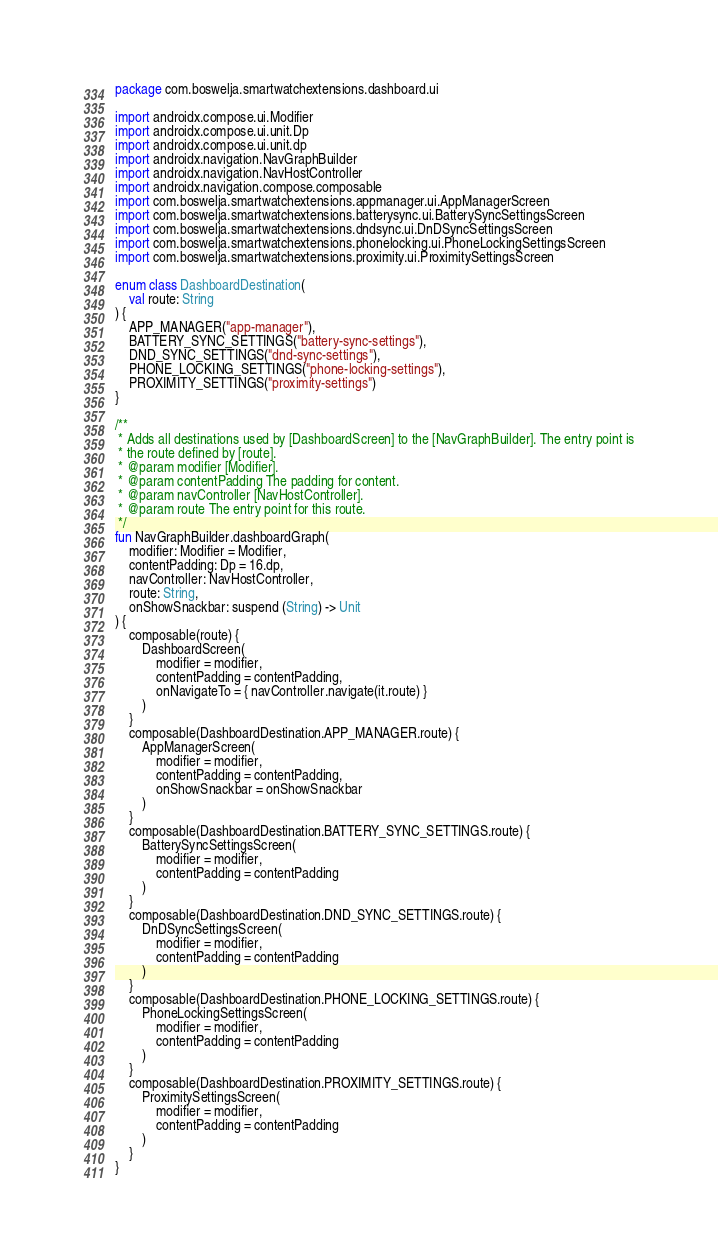Convert code to text. <code><loc_0><loc_0><loc_500><loc_500><_Kotlin_>package com.boswelja.smartwatchextensions.dashboard.ui

import androidx.compose.ui.Modifier
import androidx.compose.ui.unit.Dp
import androidx.compose.ui.unit.dp
import androidx.navigation.NavGraphBuilder
import androidx.navigation.NavHostController
import androidx.navigation.compose.composable
import com.boswelja.smartwatchextensions.appmanager.ui.AppManagerScreen
import com.boswelja.smartwatchextensions.batterysync.ui.BatterySyncSettingsScreen
import com.boswelja.smartwatchextensions.dndsync.ui.DnDSyncSettingsScreen
import com.boswelja.smartwatchextensions.phonelocking.ui.PhoneLockingSettingsScreen
import com.boswelja.smartwatchextensions.proximity.ui.ProximitySettingsScreen

enum class DashboardDestination(
    val route: String
) {
    APP_MANAGER("app-manager"),
    BATTERY_SYNC_SETTINGS("battery-sync-settings"),
    DND_SYNC_SETTINGS("dnd-sync-settings"),
    PHONE_LOCKING_SETTINGS("phone-locking-settings"),
    PROXIMITY_SETTINGS("proximity-settings")
}

/**
 * Adds all destinations used by [DashboardScreen] to the [NavGraphBuilder]. The entry point is
 * the route defined by [route].
 * @param modifier [Modifier].
 * @param contentPadding The padding for content.
 * @param navController [NavHostController].
 * @param route The entry point for this route.
 */
fun NavGraphBuilder.dashboardGraph(
    modifier: Modifier = Modifier,
    contentPadding: Dp = 16.dp,
    navController: NavHostController,
    route: String,
    onShowSnackbar: suspend (String) -> Unit
) {
    composable(route) {
        DashboardScreen(
            modifier = modifier,
            contentPadding = contentPadding,
            onNavigateTo = { navController.navigate(it.route) }
        )
    }
    composable(DashboardDestination.APP_MANAGER.route) {
        AppManagerScreen(
            modifier = modifier,
            contentPadding = contentPadding,
            onShowSnackbar = onShowSnackbar
        )
    }
    composable(DashboardDestination.BATTERY_SYNC_SETTINGS.route) {
        BatterySyncSettingsScreen(
            modifier = modifier,
            contentPadding = contentPadding
        )
    }
    composable(DashboardDestination.DND_SYNC_SETTINGS.route) {
        DnDSyncSettingsScreen(
            modifier = modifier,
            contentPadding = contentPadding
        )
    }
    composable(DashboardDestination.PHONE_LOCKING_SETTINGS.route) {
        PhoneLockingSettingsScreen(
            modifier = modifier,
            contentPadding = contentPadding
        )
    }
    composable(DashboardDestination.PROXIMITY_SETTINGS.route) {
        ProximitySettingsScreen(
            modifier = modifier,
            contentPadding = contentPadding
        )
    }
}
</code> 